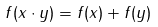<formula> <loc_0><loc_0><loc_500><loc_500>f ( x \cdot y ) = f ( x ) + f ( y )</formula> 